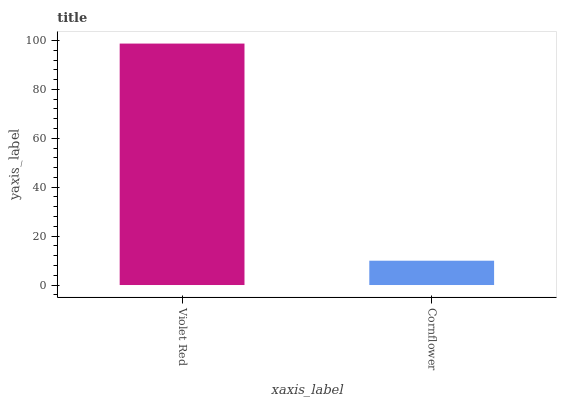Is Cornflower the minimum?
Answer yes or no. Yes. Is Violet Red the maximum?
Answer yes or no. Yes. Is Cornflower the maximum?
Answer yes or no. No. Is Violet Red greater than Cornflower?
Answer yes or no. Yes. Is Cornflower less than Violet Red?
Answer yes or no. Yes. Is Cornflower greater than Violet Red?
Answer yes or no. No. Is Violet Red less than Cornflower?
Answer yes or no. No. Is Violet Red the high median?
Answer yes or no. Yes. Is Cornflower the low median?
Answer yes or no. Yes. Is Cornflower the high median?
Answer yes or no. No. Is Violet Red the low median?
Answer yes or no. No. 